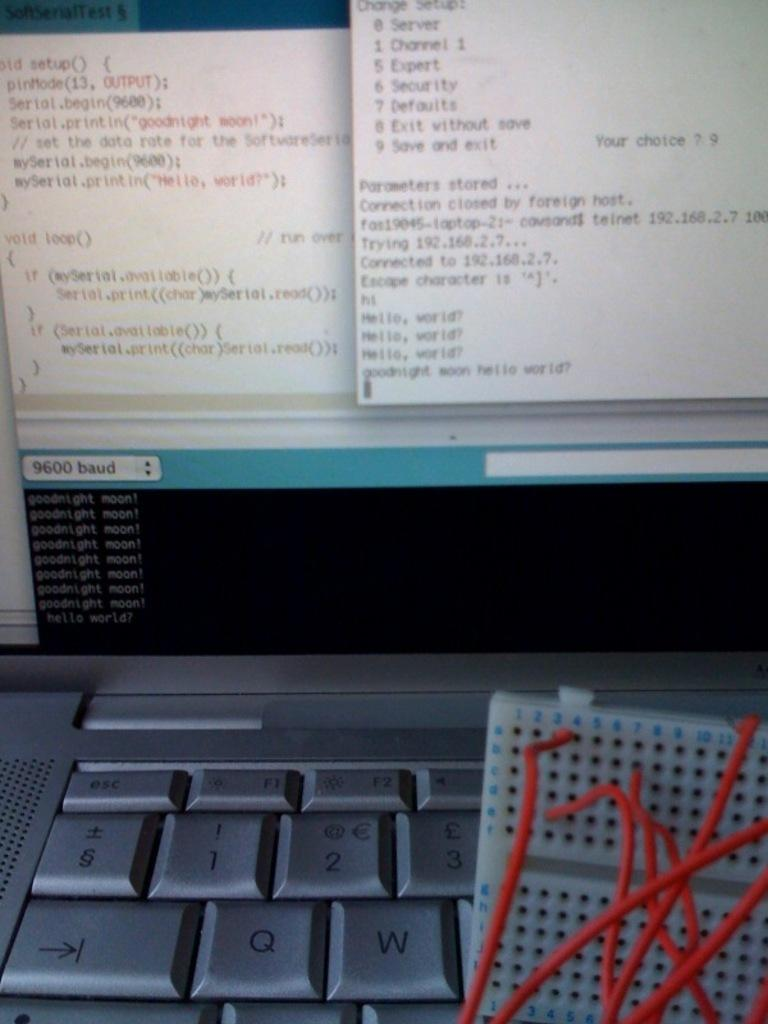<image>
Describe the image concisely. The laptop has multiple windows open and one of the windows has the words goodnight moon written. 